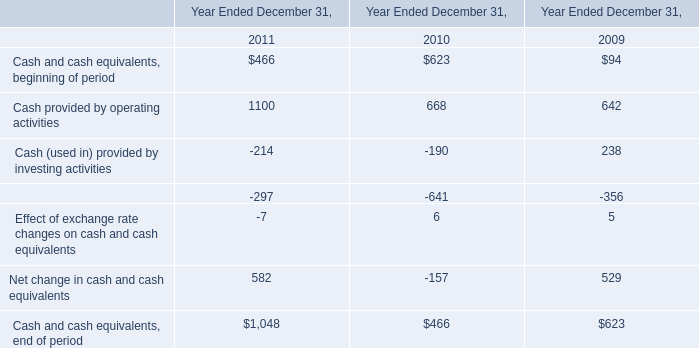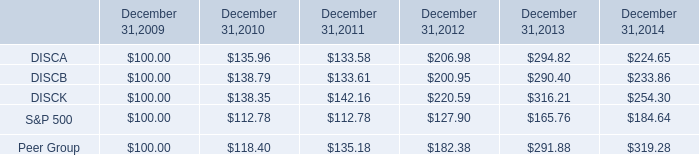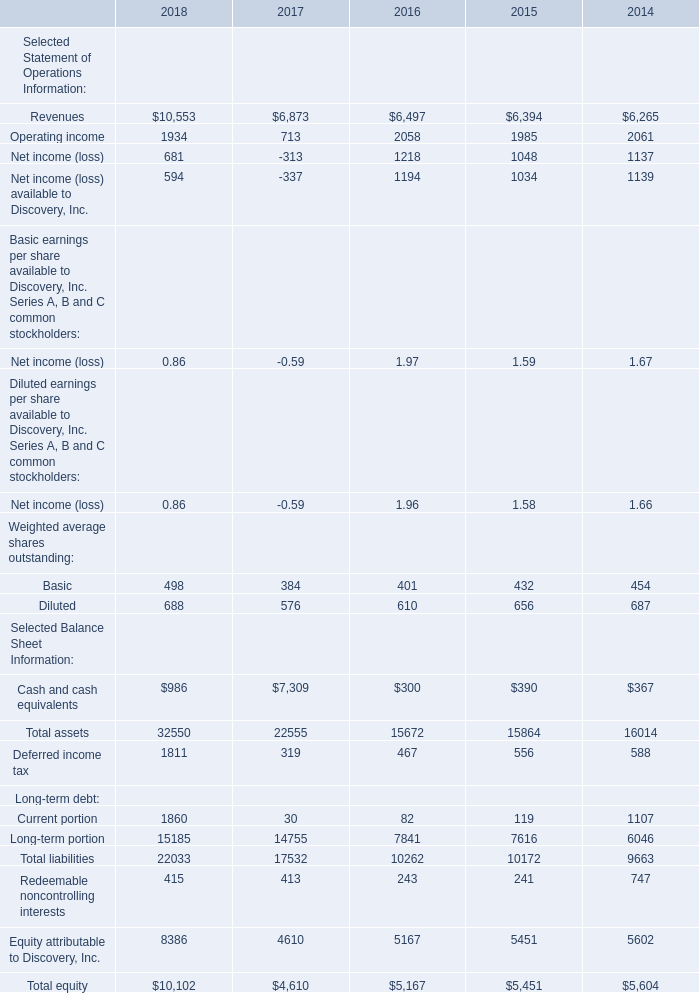What will Revenues reach in 2019 if it continues to grow at its 2018 rate? 
Computations: (10553 * (1 + ((10553 - 6873) / 6873)))
Answer: 16203.37684. 